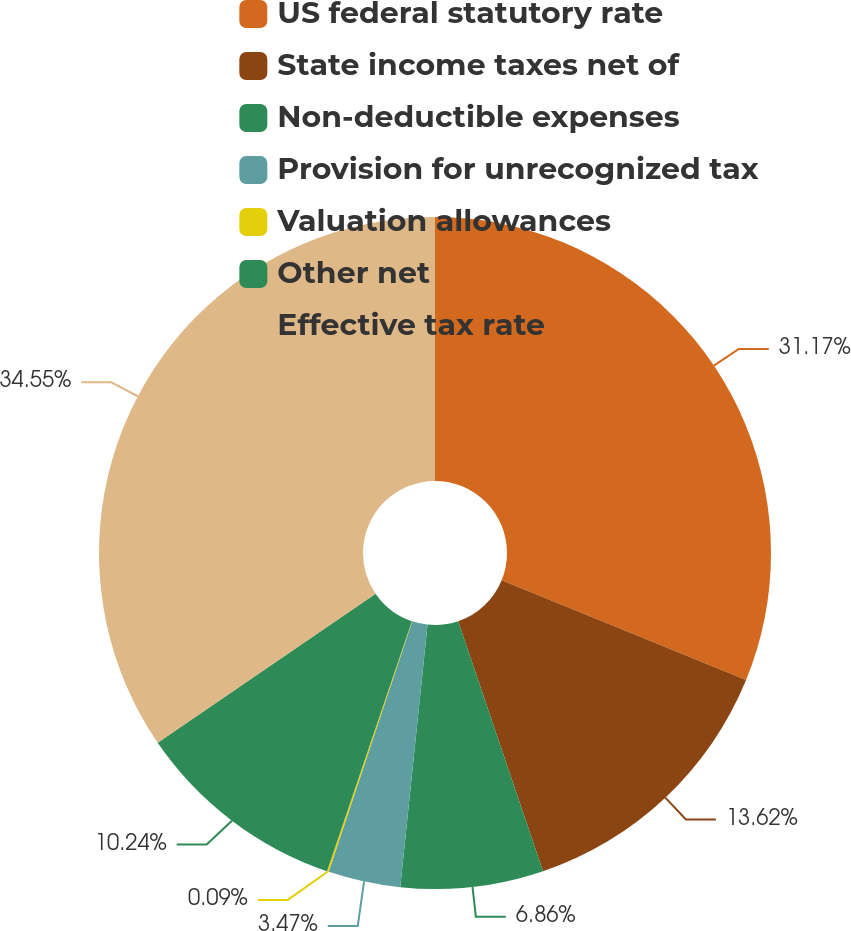<chart> <loc_0><loc_0><loc_500><loc_500><pie_chart><fcel>US federal statutory rate<fcel>State income taxes net of<fcel>Non-deductible expenses<fcel>Provision for unrecognized tax<fcel>Valuation allowances<fcel>Other net<fcel>Effective tax rate<nl><fcel>31.17%<fcel>13.62%<fcel>6.86%<fcel>3.47%<fcel>0.09%<fcel>10.24%<fcel>34.55%<nl></chart> 